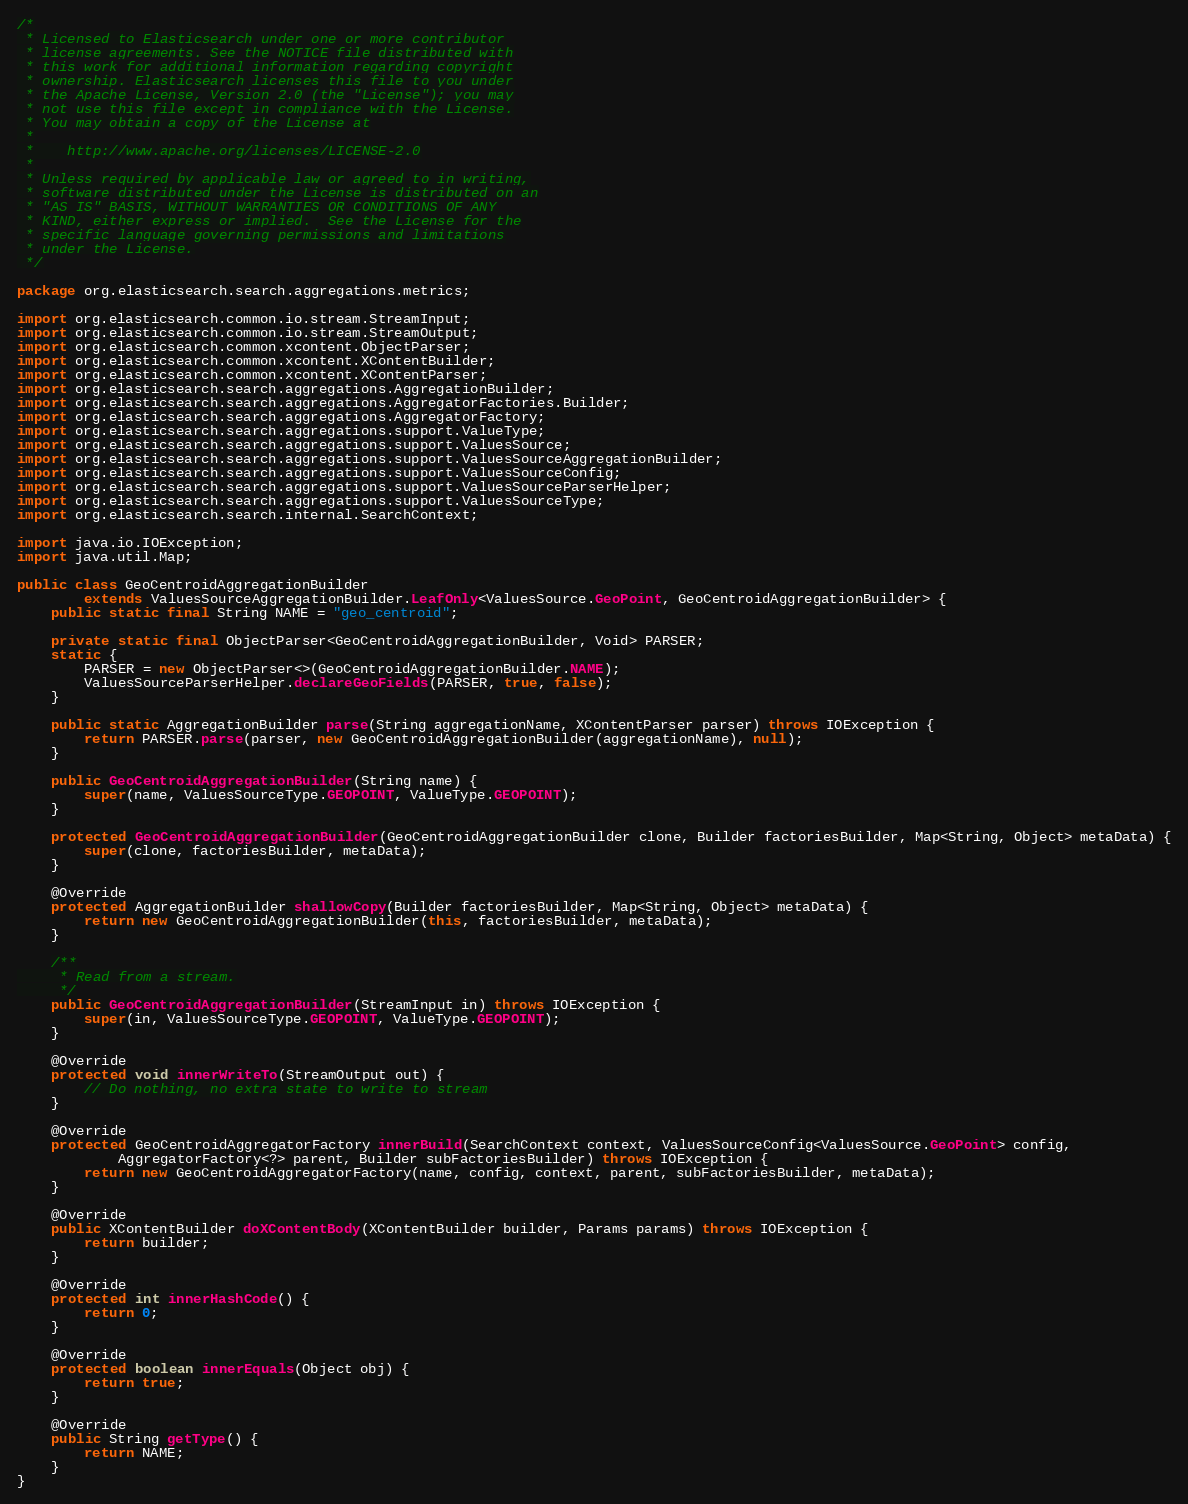<code> <loc_0><loc_0><loc_500><loc_500><_Java_>/*
 * Licensed to Elasticsearch under one or more contributor
 * license agreements. See the NOTICE file distributed with
 * this work for additional information regarding copyright
 * ownership. Elasticsearch licenses this file to you under
 * the Apache License, Version 2.0 (the "License"); you may
 * not use this file except in compliance with the License.
 * You may obtain a copy of the License at
 *
 *    http://www.apache.org/licenses/LICENSE-2.0
 *
 * Unless required by applicable law or agreed to in writing,
 * software distributed under the License is distributed on an
 * "AS IS" BASIS, WITHOUT WARRANTIES OR CONDITIONS OF ANY
 * KIND, either express or implied.  See the License for the
 * specific language governing permissions and limitations
 * under the License.
 */

package org.elasticsearch.search.aggregations.metrics;

import org.elasticsearch.common.io.stream.StreamInput;
import org.elasticsearch.common.io.stream.StreamOutput;
import org.elasticsearch.common.xcontent.ObjectParser;
import org.elasticsearch.common.xcontent.XContentBuilder;
import org.elasticsearch.common.xcontent.XContentParser;
import org.elasticsearch.search.aggregations.AggregationBuilder;
import org.elasticsearch.search.aggregations.AggregatorFactories.Builder;
import org.elasticsearch.search.aggregations.AggregatorFactory;
import org.elasticsearch.search.aggregations.support.ValueType;
import org.elasticsearch.search.aggregations.support.ValuesSource;
import org.elasticsearch.search.aggregations.support.ValuesSourceAggregationBuilder;
import org.elasticsearch.search.aggregations.support.ValuesSourceConfig;
import org.elasticsearch.search.aggregations.support.ValuesSourceParserHelper;
import org.elasticsearch.search.aggregations.support.ValuesSourceType;
import org.elasticsearch.search.internal.SearchContext;

import java.io.IOException;
import java.util.Map;

public class GeoCentroidAggregationBuilder
        extends ValuesSourceAggregationBuilder.LeafOnly<ValuesSource.GeoPoint, GeoCentroidAggregationBuilder> {
    public static final String NAME = "geo_centroid";

    private static final ObjectParser<GeoCentroidAggregationBuilder, Void> PARSER;
    static {
        PARSER = new ObjectParser<>(GeoCentroidAggregationBuilder.NAME);
        ValuesSourceParserHelper.declareGeoFields(PARSER, true, false);
    }

    public static AggregationBuilder parse(String aggregationName, XContentParser parser) throws IOException {
        return PARSER.parse(parser, new GeoCentroidAggregationBuilder(aggregationName), null);
    }

    public GeoCentroidAggregationBuilder(String name) {
        super(name, ValuesSourceType.GEOPOINT, ValueType.GEOPOINT);
    }

    protected GeoCentroidAggregationBuilder(GeoCentroidAggregationBuilder clone, Builder factoriesBuilder, Map<String, Object> metaData) {
        super(clone, factoriesBuilder, metaData);
    }

    @Override
    protected AggregationBuilder shallowCopy(Builder factoriesBuilder, Map<String, Object> metaData) {
        return new GeoCentroidAggregationBuilder(this, factoriesBuilder, metaData);
    }

    /**
     * Read from a stream.
     */
    public GeoCentroidAggregationBuilder(StreamInput in) throws IOException {
        super(in, ValuesSourceType.GEOPOINT, ValueType.GEOPOINT);
    }

    @Override
    protected void innerWriteTo(StreamOutput out) {
        // Do nothing, no extra state to write to stream
    }

    @Override
    protected GeoCentroidAggregatorFactory innerBuild(SearchContext context, ValuesSourceConfig<ValuesSource.GeoPoint> config,
            AggregatorFactory<?> parent, Builder subFactoriesBuilder) throws IOException {
        return new GeoCentroidAggregatorFactory(name, config, context, parent, subFactoriesBuilder, metaData);
    }

    @Override
    public XContentBuilder doXContentBody(XContentBuilder builder, Params params) throws IOException {
        return builder;
    }

    @Override
    protected int innerHashCode() {
        return 0;
    }

    @Override
    protected boolean innerEquals(Object obj) {
        return true;
    }

    @Override
    public String getType() {
        return NAME;
    }
}
</code> 